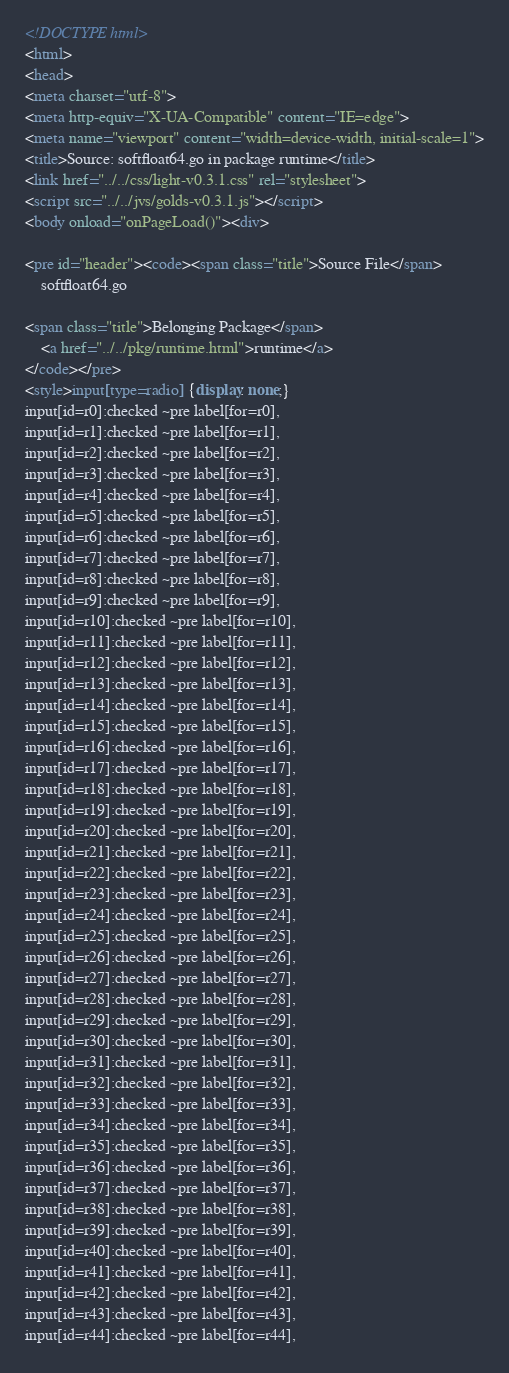<code> <loc_0><loc_0><loc_500><loc_500><_HTML_><!DOCTYPE html>
<html>
<head>
<meta charset="utf-8">
<meta http-equiv="X-UA-Compatible" content="IE=edge">
<meta name="viewport" content="width=device-width, initial-scale=1">
<title>Source: softfloat64.go in package runtime</title>
<link href="../../css/light-v0.3.1.css" rel="stylesheet">
<script src="../../jvs/golds-v0.3.1.js"></script>
<body onload="onPageLoad()"><div>

<pre id="header"><code><span class="title">Source File</span>
	softfloat64.go

<span class="title">Belonging Package</span>
	<a href="../../pkg/runtime.html">runtime</a>
</code></pre>
<style>input[type=radio] {display: none;}
input[id=r0]:checked ~pre label[for=r0],
input[id=r1]:checked ~pre label[for=r1],
input[id=r2]:checked ~pre label[for=r2],
input[id=r3]:checked ~pre label[for=r3],
input[id=r4]:checked ~pre label[for=r4],
input[id=r5]:checked ~pre label[for=r5],
input[id=r6]:checked ~pre label[for=r6],
input[id=r7]:checked ~pre label[for=r7],
input[id=r8]:checked ~pre label[for=r8],
input[id=r9]:checked ~pre label[for=r9],
input[id=r10]:checked ~pre label[for=r10],
input[id=r11]:checked ~pre label[for=r11],
input[id=r12]:checked ~pre label[for=r12],
input[id=r13]:checked ~pre label[for=r13],
input[id=r14]:checked ~pre label[for=r14],
input[id=r15]:checked ~pre label[for=r15],
input[id=r16]:checked ~pre label[for=r16],
input[id=r17]:checked ~pre label[for=r17],
input[id=r18]:checked ~pre label[for=r18],
input[id=r19]:checked ~pre label[for=r19],
input[id=r20]:checked ~pre label[for=r20],
input[id=r21]:checked ~pre label[for=r21],
input[id=r22]:checked ~pre label[for=r22],
input[id=r23]:checked ~pre label[for=r23],
input[id=r24]:checked ~pre label[for=r24],
input[id=r25]:checked ~pre label[for=r25],
input[id=r26]:checked ~pre label[for=r26],
input[id=r27]:checked ~pre label[for=r27],
input[id=r28]:checked ~pre label[for=r28],
input[id=r29]:checked ~pre label[for=r29],
input[id=r30]:checked ~pre label[for=r30],
input[id=r31]:checked ~pre label[for=r31],
input[id=r32]:checked ~pre label[for=r32],
input[id=r33]:checked ~pre label[for=r33],
input[id=r34]:checked ~pre label[for=r34],
input[id=r35]:checked ~pre label[for=r35],
input[id=r36]:checked ~pre label[for=r36],
input[id=r37]:checked ~pre label[for=r37],
input[id=r38]:checked ~pre label[for=r38],
input[id=r39]:checked ~pre label[for=r39],
input[id=r40]:checked ~pre label[for=r40],
input[id=r41]:checked ~pre label[for=r41],
input[id=r42]:checked ~pre label[for=r42],
input[id=r43]:checked ~pre label[for=r43],
input[id=r44]:checked ~pre label[for=r44],</code> 